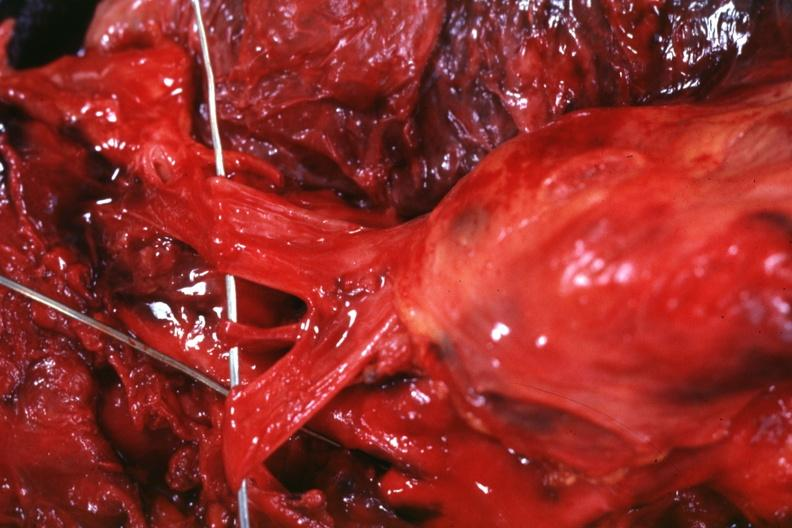s thymus present?
Answer the question using a single word or phrase. No 